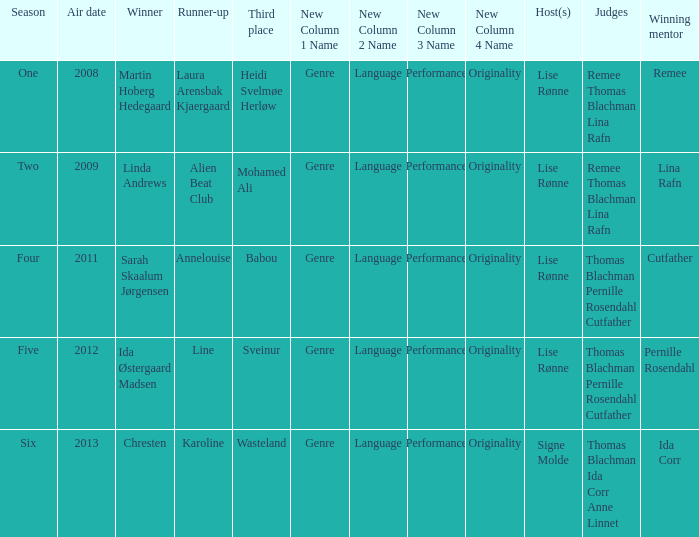Who won third place in season four? Babou. 